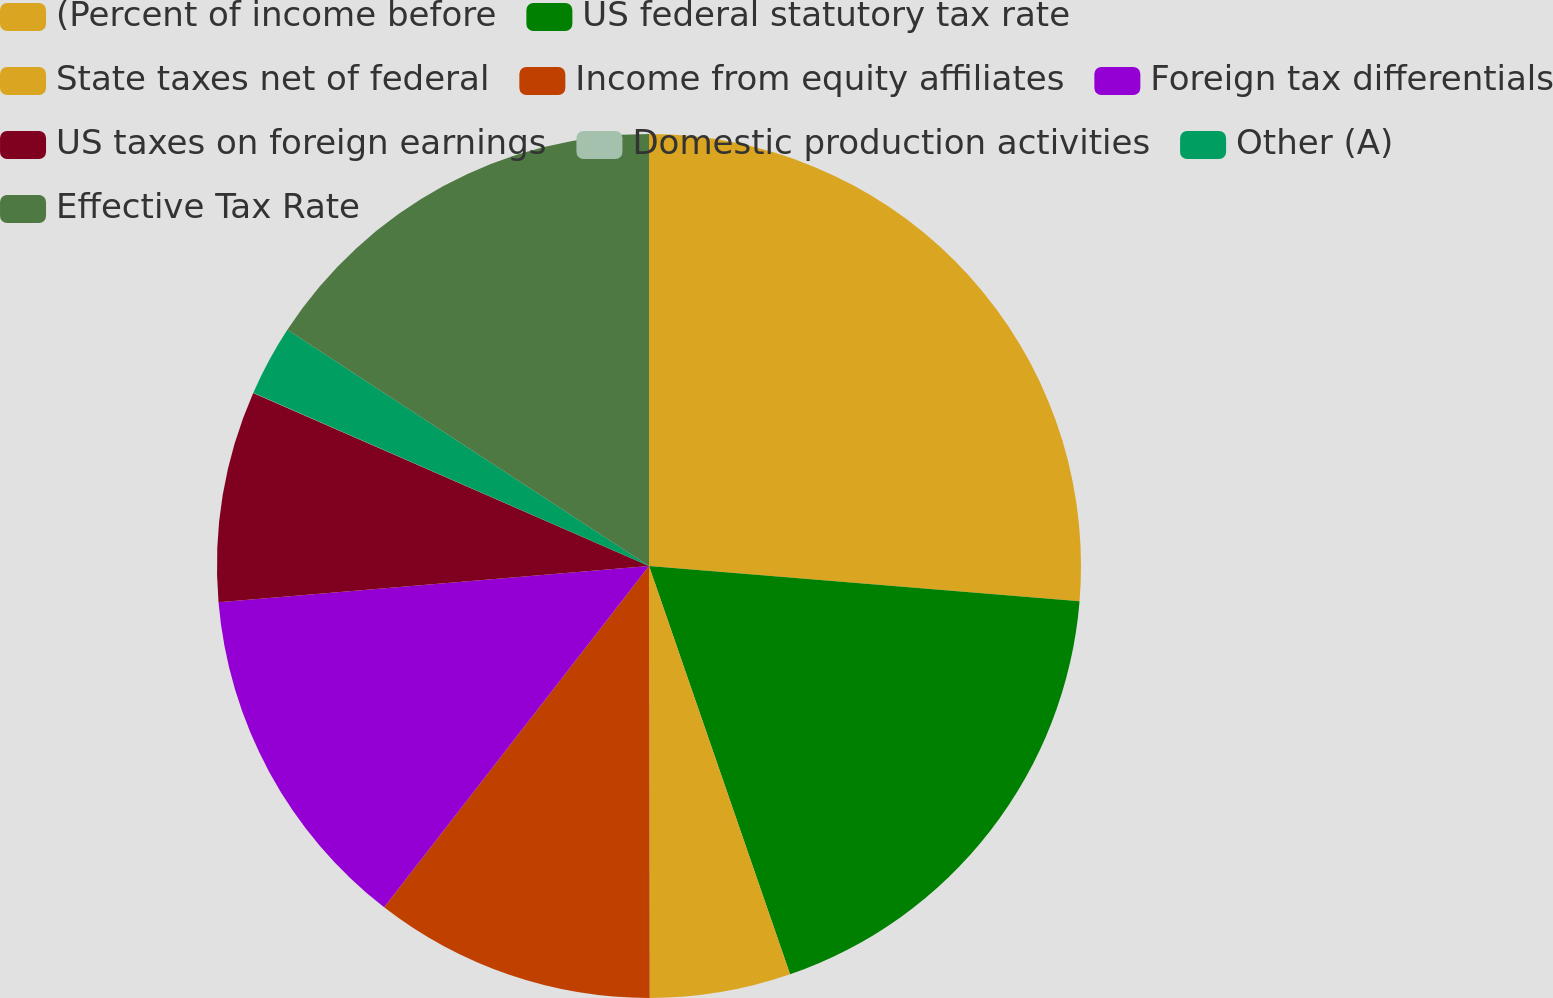Convert chart to OTSL. <chart><loc_0><loc_0><loc_500><loc_500><pie_chart><fcel>(Percent of income before<fcel>US federal statutory tax rate<fcel>State taxes net of federal<fcel>Income from equity affiliates<fcel>Foreign tax differentials<fcel>US taxes on foreign earnings<fcel>Domestic production activities<fcel>Other (A)<fcel>Effective Tax Rate<nl><fcel>26.3%<fcel>18.41%<fcel>5.27%<fcel>10.53%<fcel>13.16%<fcel>7.9%<fcel>0.01%<fcel>2.64%<fcel>15.79%<nl></chart> 